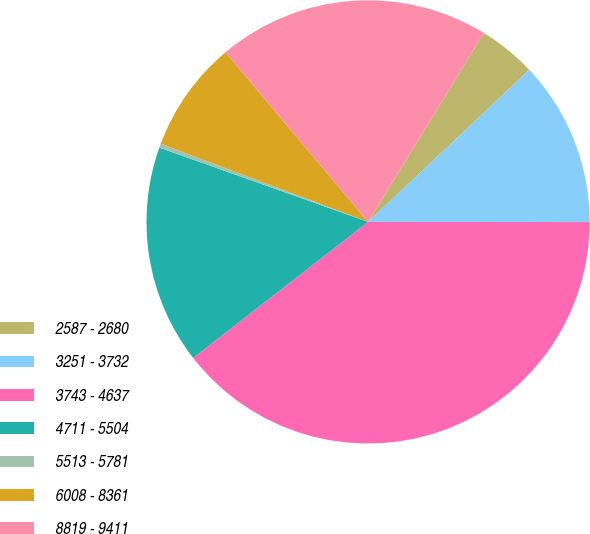<chart> <loc_0><loc_0><loc_500><loc_500><pie_chart><fcel>2587 - 2680<fcel>3251 - 3732<fcel>3743 - 4637<fcel>4711 - 5504<fcel>5513 - 5781<fcel>6008 - 8361<fcel>8819 - 9411<nl><fcel>4.21%<fcel>12.05%<fcel>39.47%<fcel>15.96%<fcel>0.3%<fcel>8.13%<fcel>19.88%<nl></chart> 